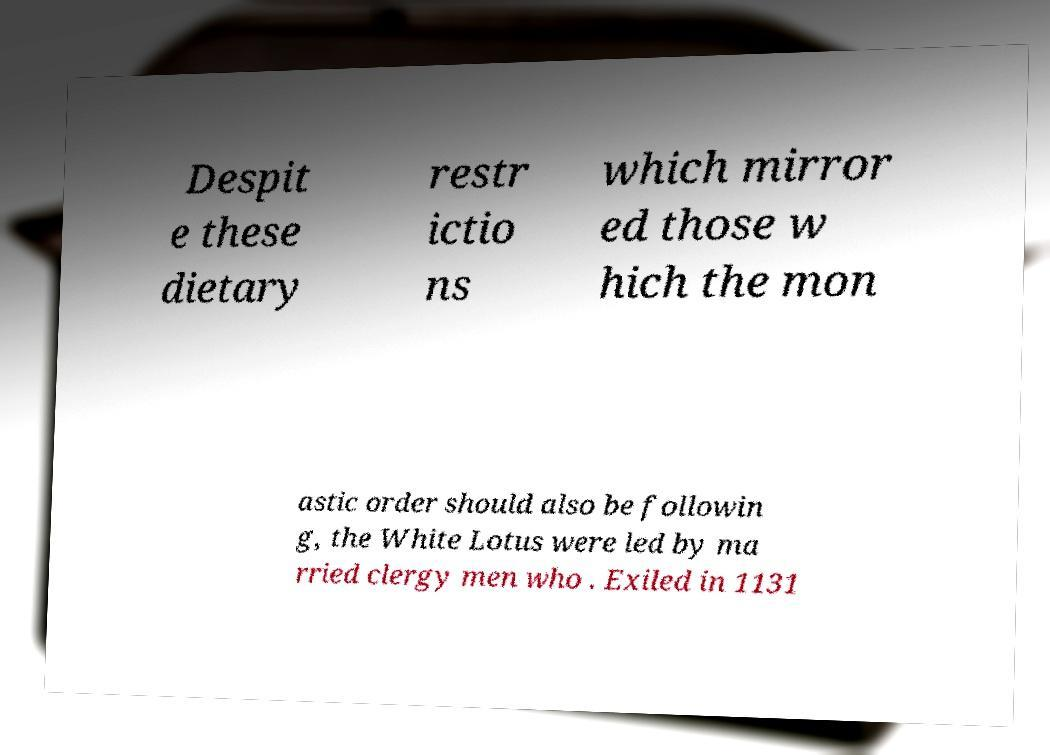There's text embedded in this image that I need extracted. Can you transcribe it verbatim? Despit e these dietary restr ictio ns which mirror ed those w hich the mon astic order should also be followin g, the White Lotus were led by ma rried clergy men who . Exiled in 1131 